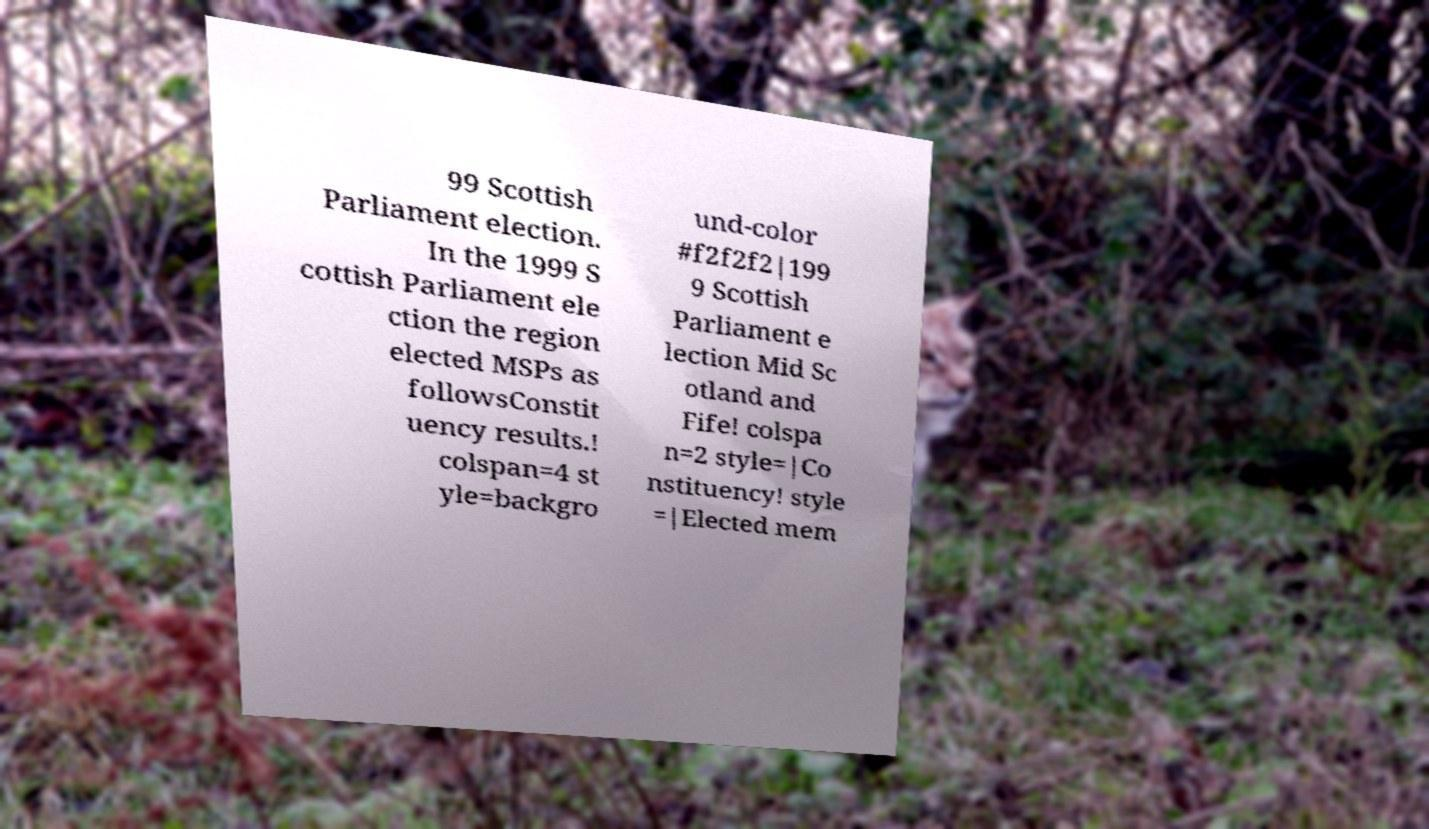Could you extract and type out the text from this image? 99 Scottish Parliament election. In the 1999 S cottish Parliament ele ction the region elected MSPs as followsConstit uency results.! colspan=4 st yle=backgro und-color #f2f2f2|199 9 Scottish Parliament e lection Mid Sc otland and Fife! colspa n=2 style=|Co nstituency! style =|Elected mem 